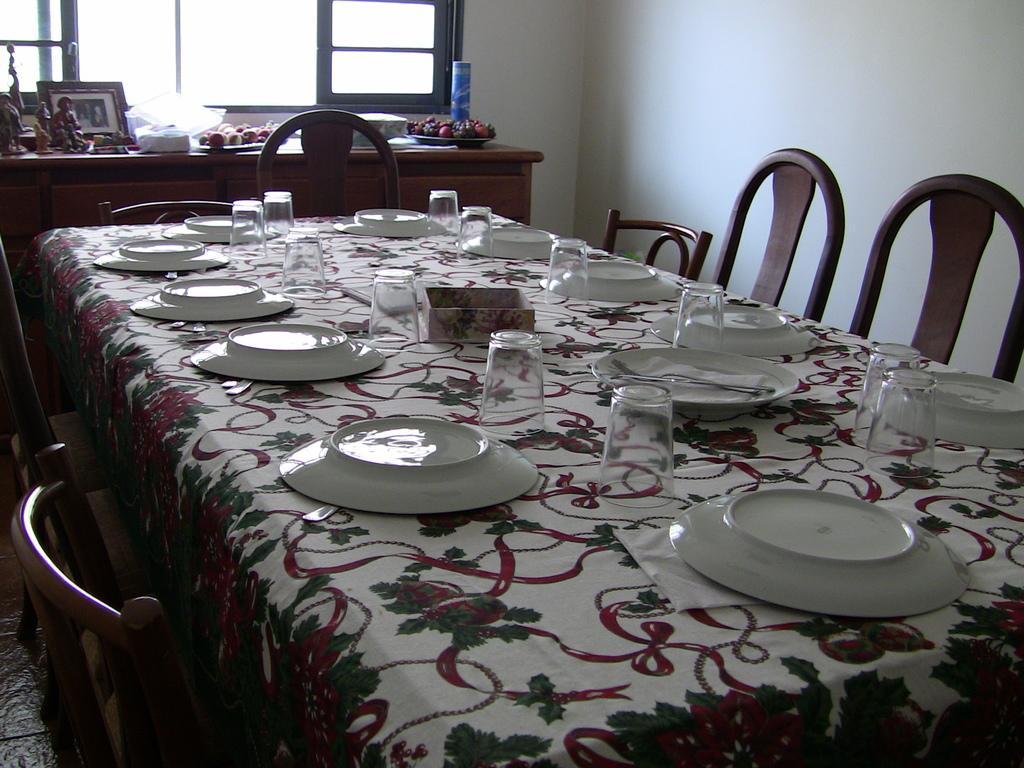Can you describe this image briefly? In this image there is a table, on that table there is a cloth, on that cloth there are plates, glasses, spoons, around the table there are chairs, in the background there is a cabinet, on that there are few objects and there is a wall for that wall there is a window. 